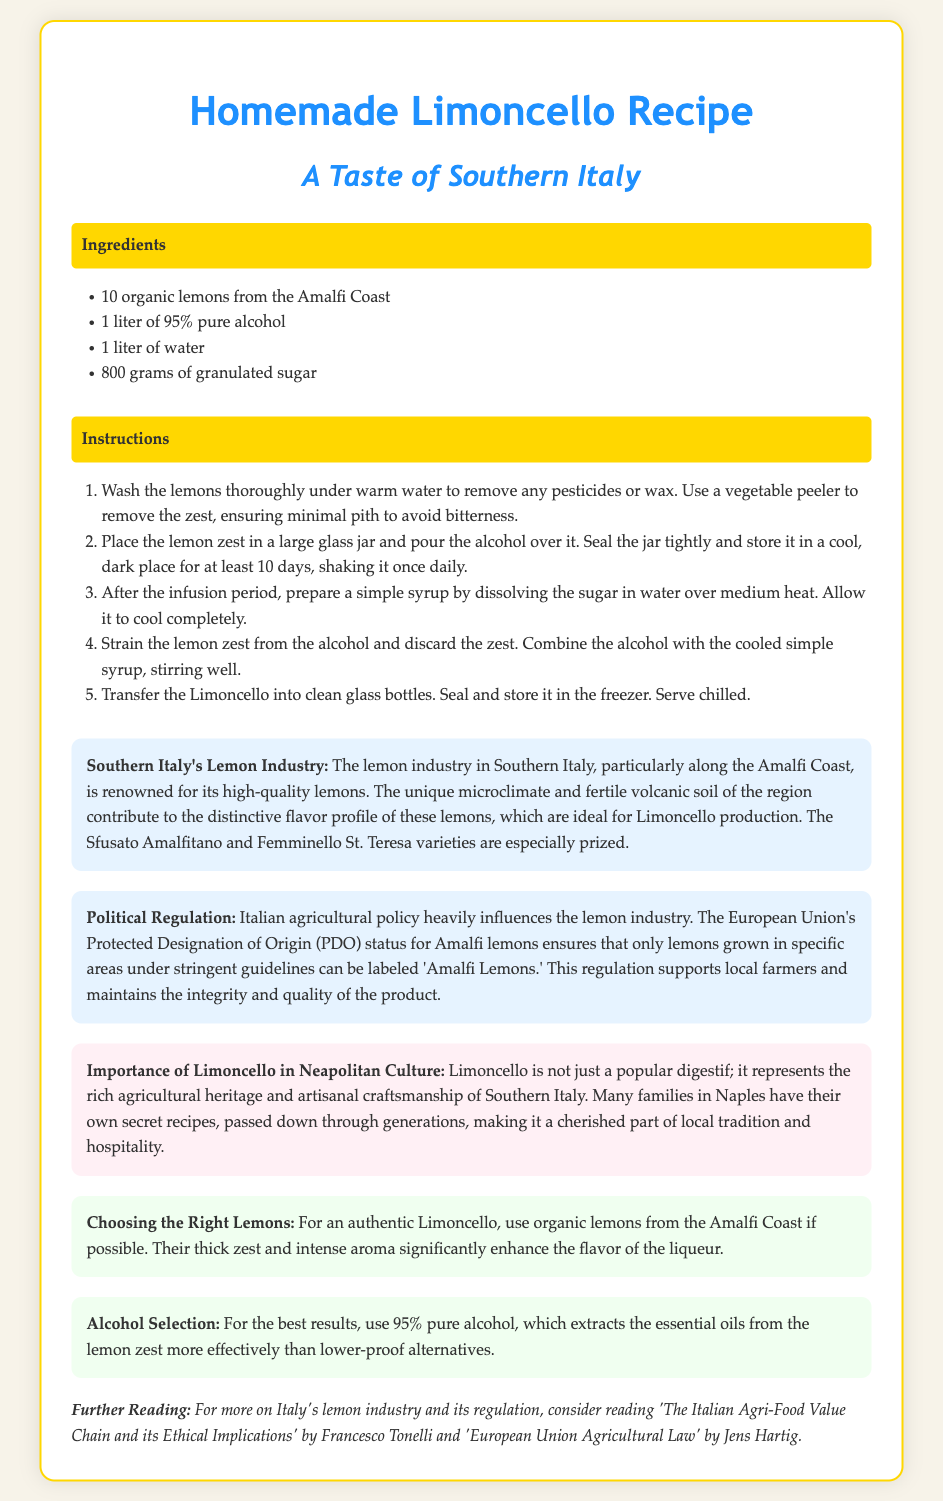What are the main types of lemons mentioned? The document specifies two types of lemons, Sfusato Amalfitano and Femminello St. Teresa, which are particularly prized for Limoncello production.
Answer: Sfusato Amalfitano, Femminello St. Teresa How long should the lemon zest be infused with alcohol? The instructions state that the lemon zest should be infused with alcohol for at least 10 days, with daily shaking.
Answer: 10 days What is the alcohol percentage used in this recipe? The recipe specifies the use of 95% pure alcohol, which is ideal for extracting the flavor from the lemon zest.
Answer: 95% What is the purpose of the Protected Designation of Origin status? The document explains that this status ensures that only lemons grown in specific areas under stringent guidelines can be labeled 'Amalfi Lemons,' supporting local farmers.
Answer: Supports local farmers What kind of syrup is prepared in the recipe? The recipe indicates that a simple syrup is prepared by dissolving sugar in water over medium heat.
Answer: Simple syrup Why is it important to use organic lemons? The tip advises that organic lemons from the Amalfi Coast enhance the flavor due to their thick zest and intense aroma, making them suitable for authentic Limoncello.
Answer: Enhance flavor What is Limoncello considered in Neapolitan culture? The cultural note describes Limoncello as a popular digestif and a symbol of agricultural heritage and artisanal craftsmanship in Southern Italy.
Answer: A popular digestif How is the lemon zest treated before infusion? The instructions state that the lemons should be washed thoroughly to remove pesticides or wax before removing the zest.
Answer: Washed thoroughly 